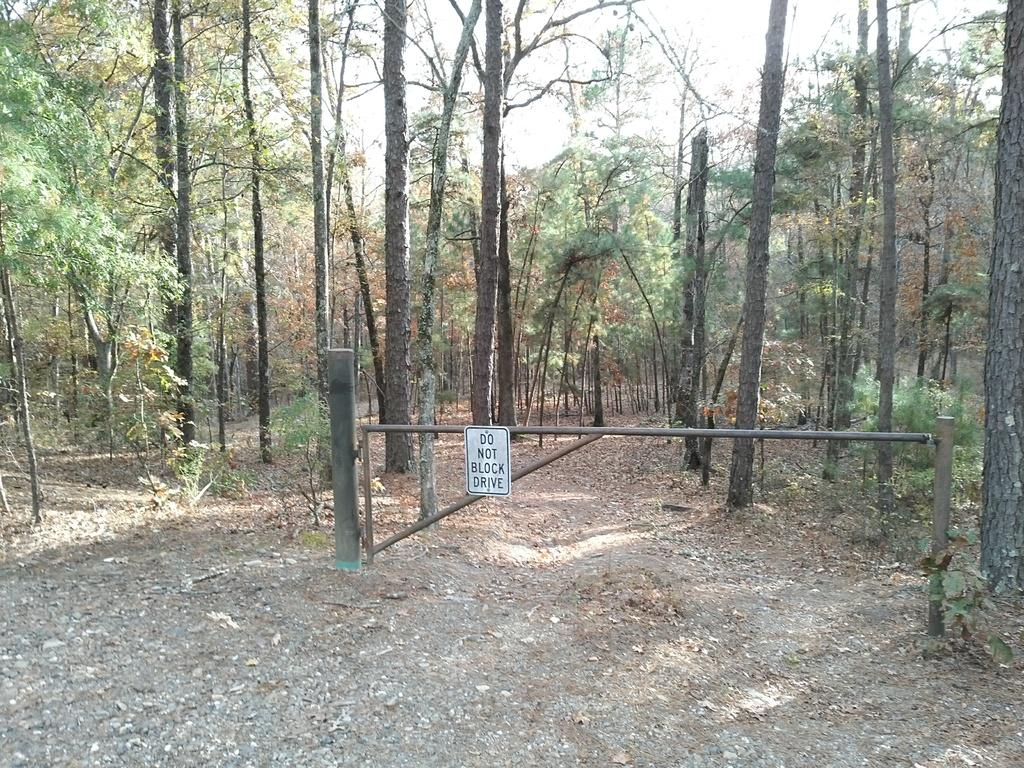What type of natural material can be seen in the image? There is some soil in the image. What other natural elements are present in the image? There are dry leaves, plants, and trees in the backdrop of the image. What man-made structure is visible in the image? There is a barrier gate in the image. What is the condition of the sky in the image? The sky is clear in the image. Can you see a kitty taking a bath in the image? There is no kitty or bath present in the image. What is the base of the barrier gate made of in the image? The provided facts do not mention the material or base of the barrier gate, so it cannot be determined from the image. 